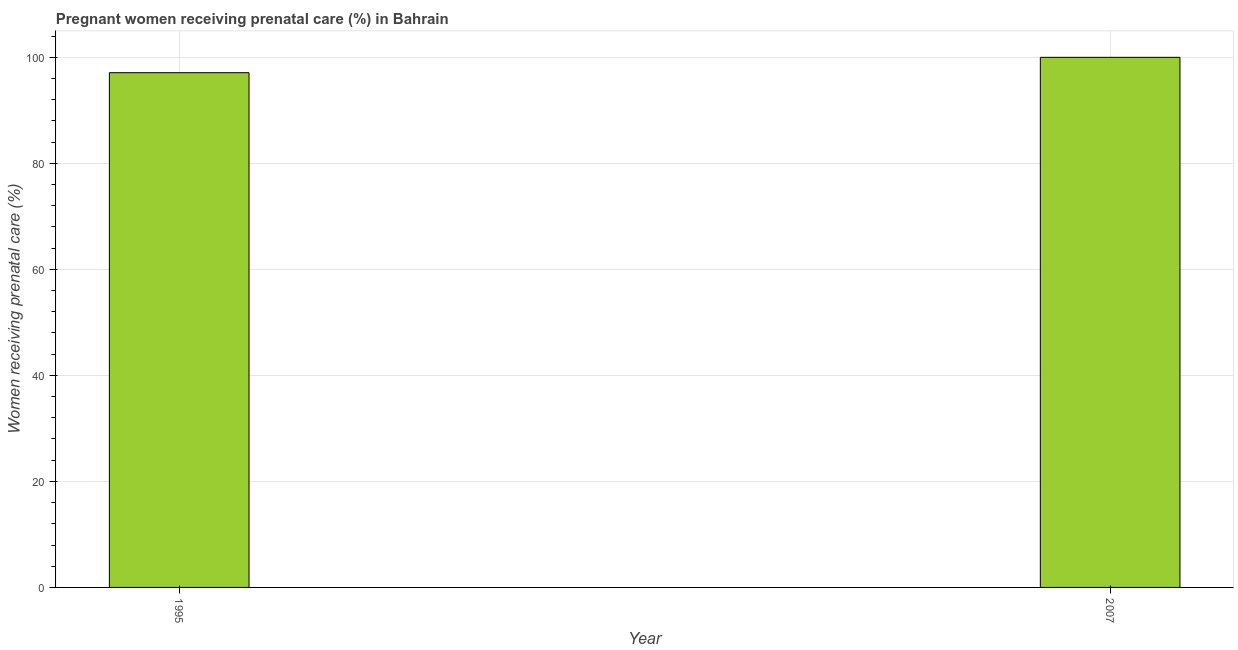Does the graph contain any zero values?
Give a very brief answer. No. What is the title of the graph?
Offer a very short reply. Pregnant women receiving prenatal care (%) in Bahrain. What is the label or title of the Y-axis?
Make the answer very short. Women receiving prenatal care (%). What is the percentage of pregnant women receiving prenatal care in 1995?
Your response must be concise. 97.1. Across all years, what is the minimum percentage of pregnant women receiving prenatal care?
Ensure brevity in your answer.  97.1. In which year was the percentage of pregnant women receiving prenatal care maximum?
Provide a short and direct response. 2007. What is the sum of the percentage of pregnant women receiving prenatal care?
Your answer should be compact. 197.1. What is the difference between the percentage of pregnant women receiving prenatal care in 1995 and 2007?
Your response must be concise. -2.9. What is the average percentage of pregnant women receiving prenatal care per year?
Keep it short and to the point. 98.55. What is the median percentage of pregnant women receiving prenatal care?
Make the answer very short. 98.55. Do a majority of the years between 1995 and 2007 (inclusive) have percentage of pregnant women receiving prenatal care greater than 84 %?
Offer a terse response. Yes. What is the ratio of the percentage of pregnant women receiving prenatal care in 1995 to that in 2007?
Ensure brevity in your answer.  0.97. In how many years, is the percentage of pregnant women receiving prenatal care greater than the average percentage of pregnant women receiving prenatal care taken over all years?
Your answer should be compact. 1. How many bars are there?
Give a very brief answer. 2. Are all the bars in the graph horizontal?
Give a very brief answer. No. What is the difference between two consecutive major ticks on the Y-axis?
Make the answer very short. 20. What is the Women receiving prenatal care (%) in 1995?
Your response must be concise. 97.1. What is the Women receiving prenatal care (%) in 2007?
Provide a short and direct response. 100. What is the difference between the Women receiving prenatal care (%) in 1995 and 2007?
Your response must be concise. -2.9. 